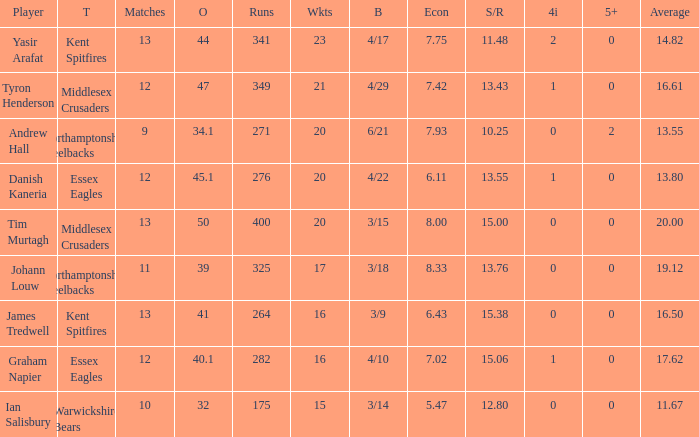Name the most 4/inns 2.0. 